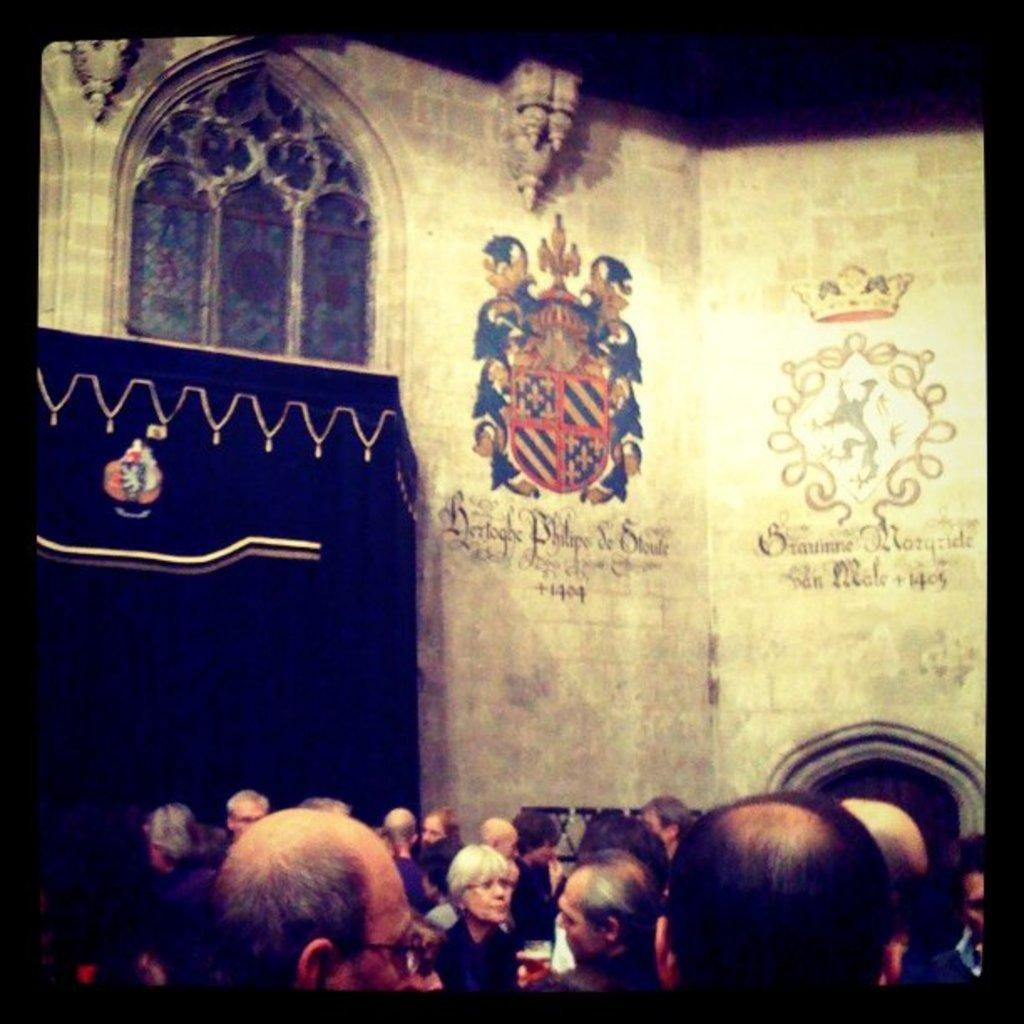How many people are in the image? There is a group of people in the image. What are the people doing in the image? The people are standing on a path. Can you describe the person holding a glass in the image? There is a person holding a glass in the image. What is visible behind the people in the image? There is a wall visible behind the people. What type of holiday is being celebrated by the ghost in the image? There is no ghost present in the image, so it is not possible to determine if a holiday is being celebrated. 